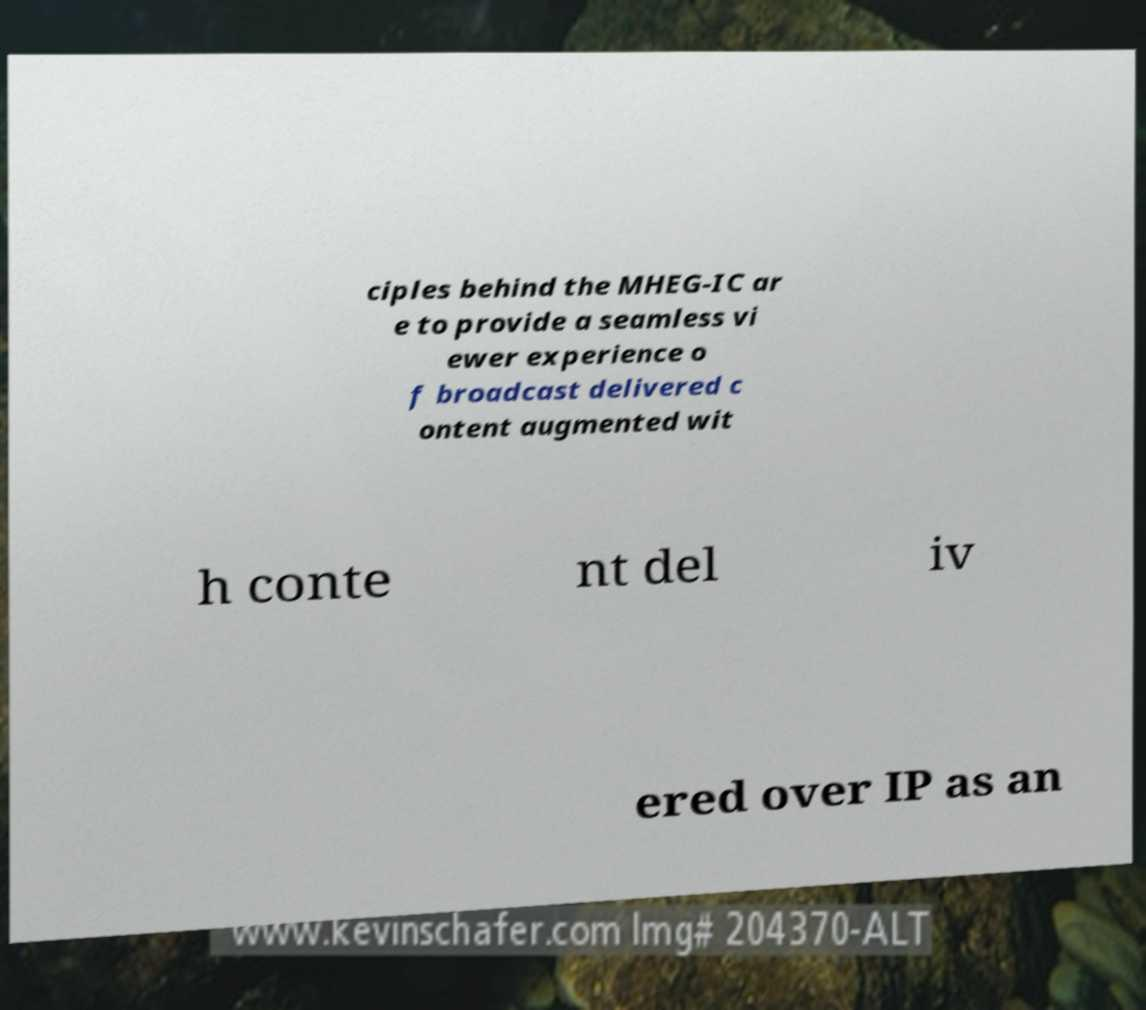Could you extract and type out the text from this image? ciples behind the MHEG-IC ar e to provide a seamless vi ewer experience o f broadcast delivered c ontent augmented wit h conte nt del iv ered over IP as an 